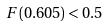Convert formula to latex. <formula><loc_0><loc_0><loc_500><loc_500>F ( 0 . 6 0 5 ) < 0 . 5</formula> 